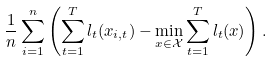<formula> <loc_0><loc_0><loc_500><loc_500>\frac { 1 } { n } \sum _ { i = 1 } ^ { n } \left ( \sum _ { t = 1 } ^ { T } l _ { t } ( x _ { i , t } ) - \min _ { x \in \mathcal { X } } \sum _ { t = 1 } ^ { T } l _ { t } ( x ) \right ) .</formula> 